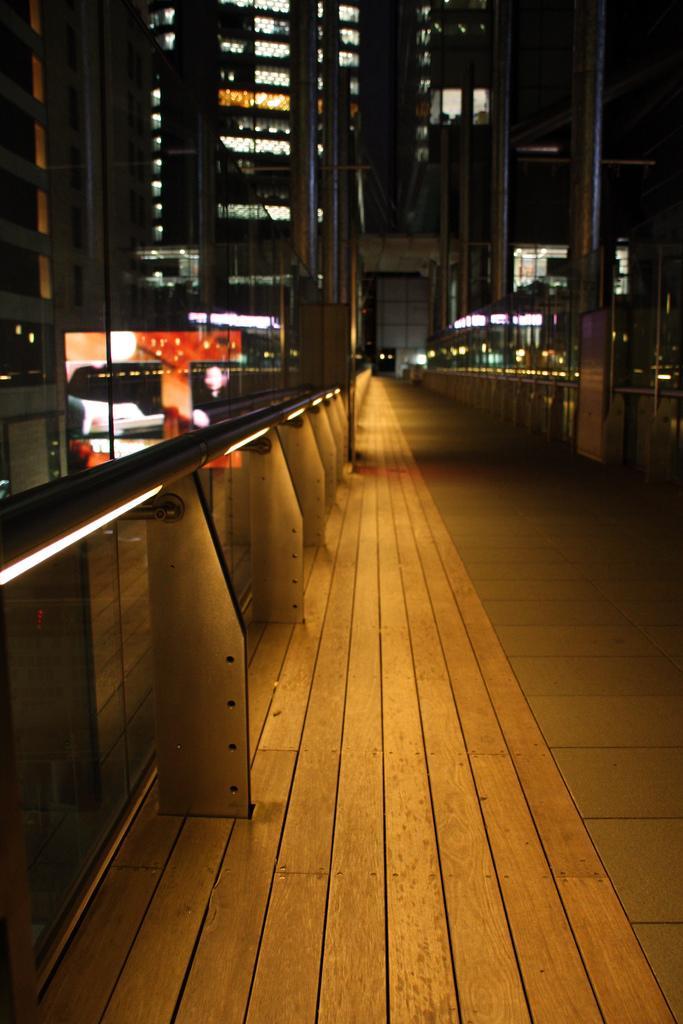In one or two sentences, can you explain what this image depicts? In this image we can see railings, poles, buildings and lights. 